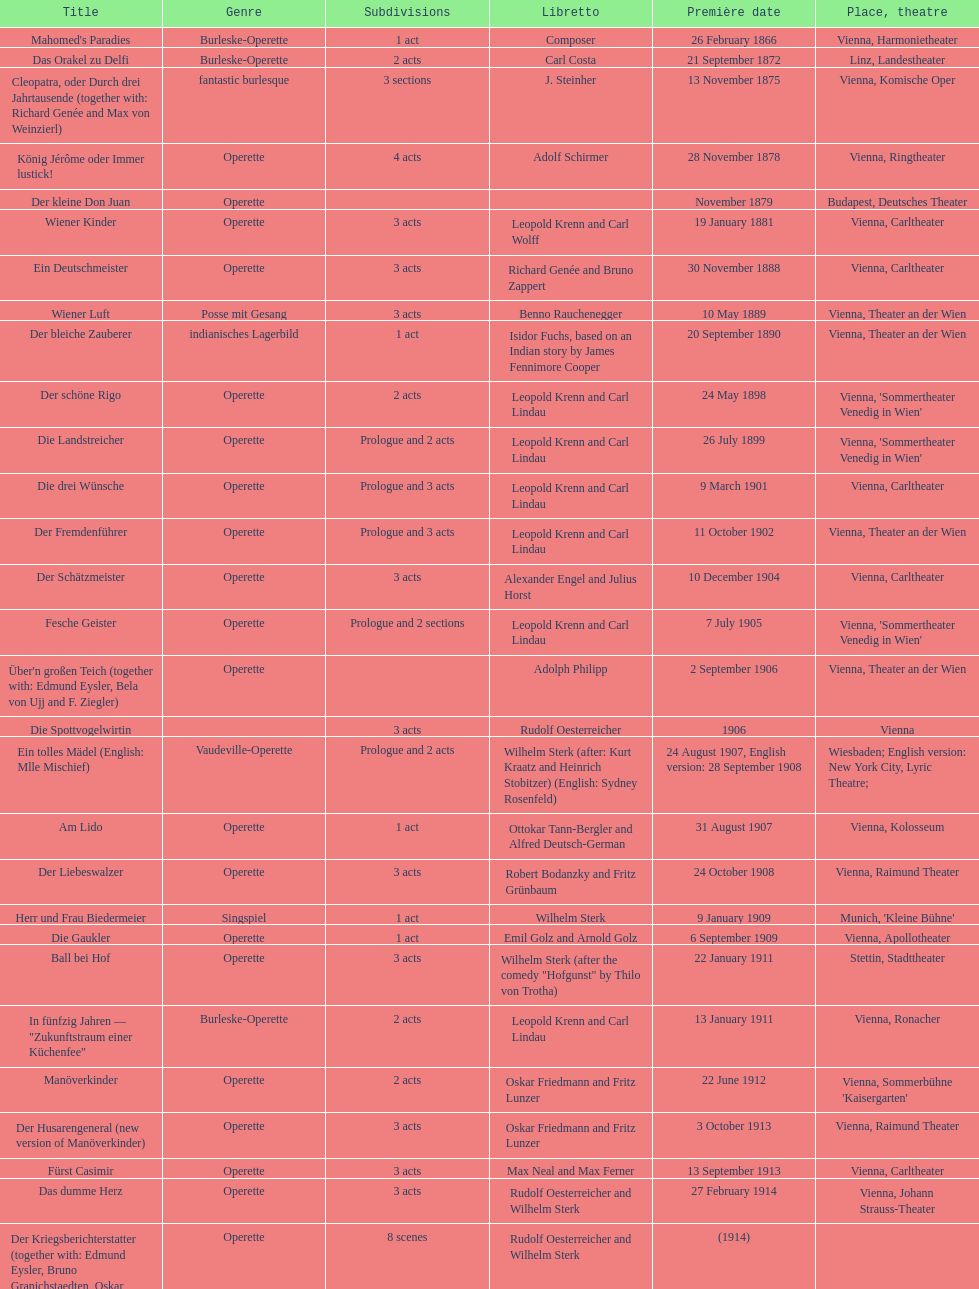Which genre is featured the most in this chart? Operette. 